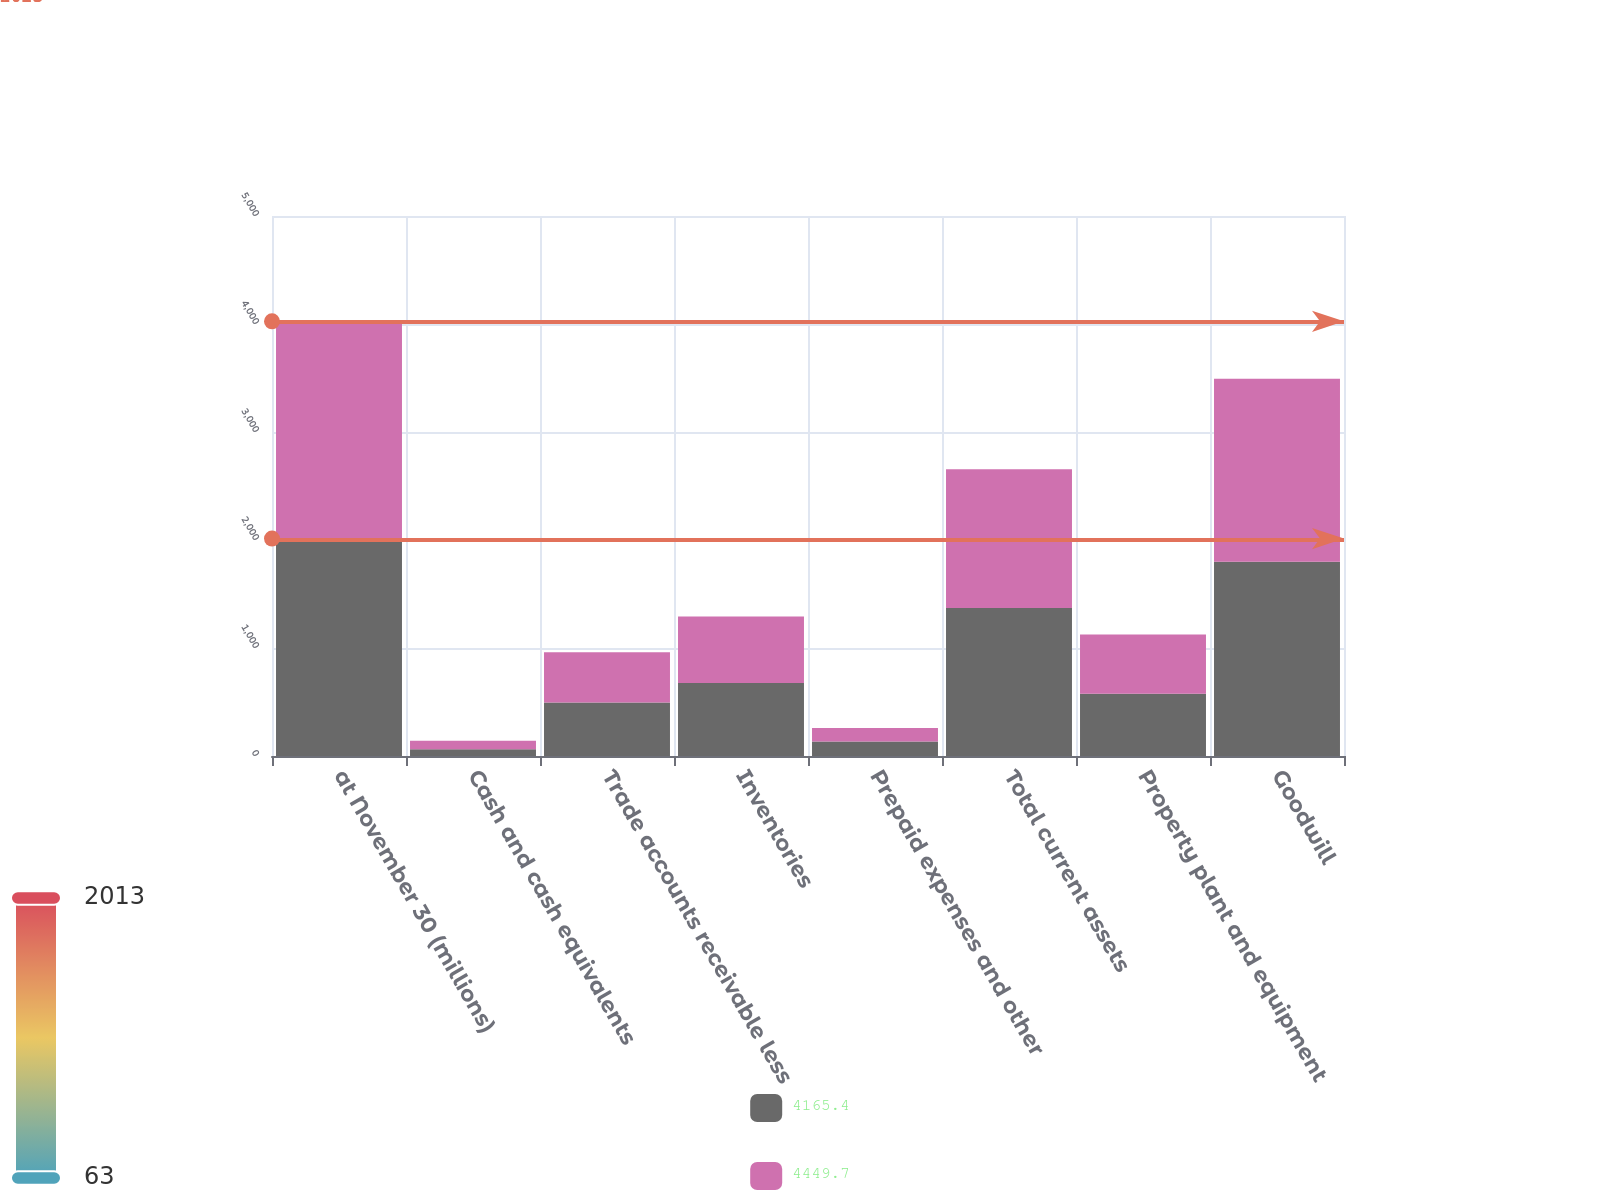<chart> <loc_0><loc_0><loc_500><loc_500><stacked_bar_chart><ecel><fcel>at November 30 (millions)<fcel>Cash and cash equivalents<fcel>Trade accounts receivable less<fcel>Inventories<fcel>Prepaid expenses and other<fcel>Total current assets<fcel>Property plant and equipment<fcel>Goodwill<nl><fcel>4165.4<fcel>2013<fcel>63<fcel>495.5<fcel>676.9<fcel>134.8<fcel>1370.2<fcel>576.6<fcel>1798.5<nl><fcel>4449.7<fcel>2012<fcel>79<fcel>465.9<fcel>615<fcel>125.5<fcel>1285.4<fcel>547.3<fcel>1695.3<nl></chart> 